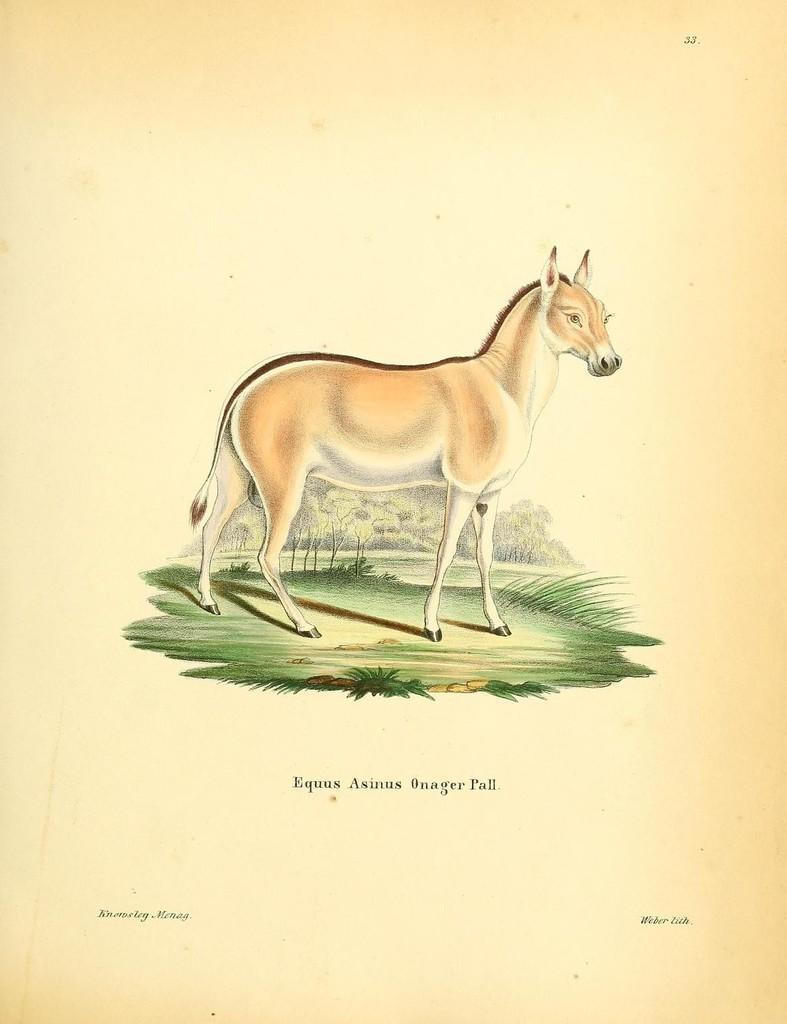How would you summarize this image in a sentence or two? In this image I can see the cream colored background and on it I can see the painting of an animal standing on the ground. In the background I can see few trees. 